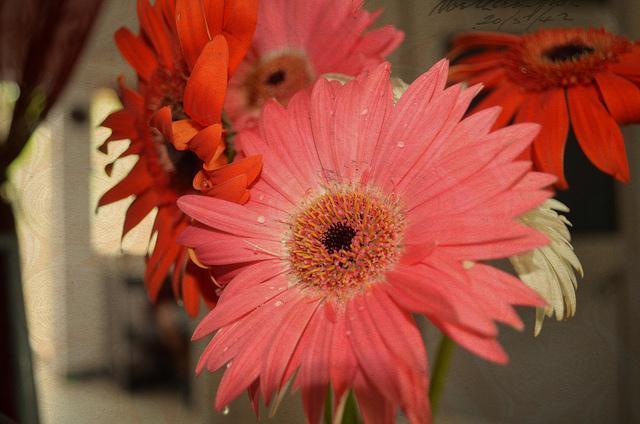How many orange papers are on the toilet?
Give a very brief answer. 0. 